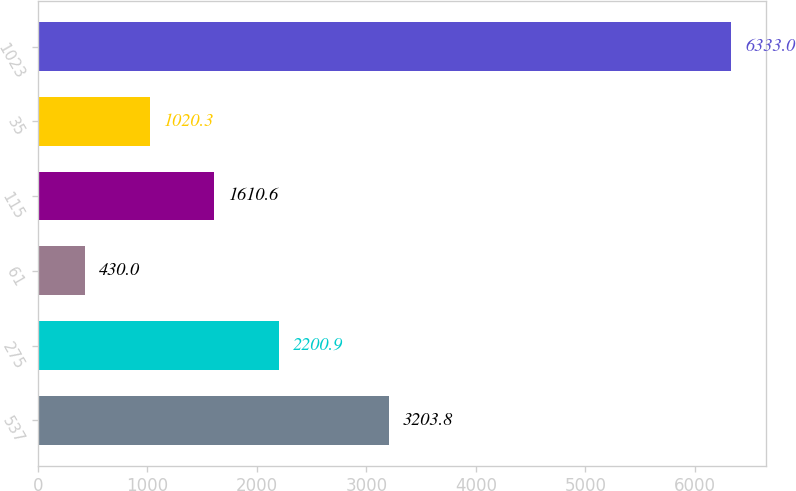Convert chart to OTSL. <chart><loc_0><loc_0><loc_500><loc_500><bar_chart><fcel>537<fcel>275<fcel>61<fcel>115<fcel>35<fcel>1023<nl><fcel>3203.8<fcel>2200.9<fcel>430<fcel>1610.6<fcel>1020.3<fcel>6333<nl></chart> 